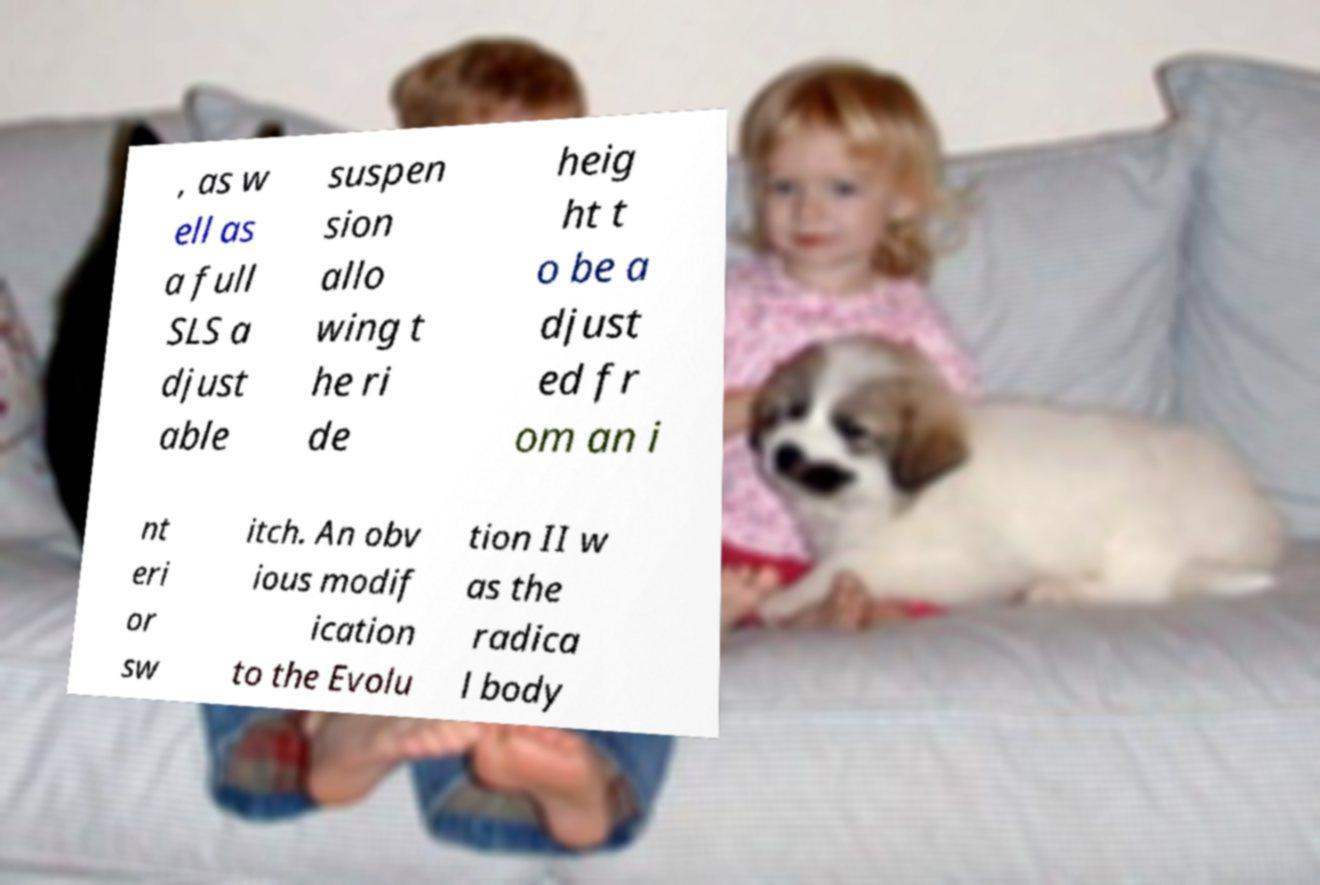Please read and relay the text visible in this image. What does it say? , as w ell as a full SLS a djust able suspen sion allo wing t he ri de heig ht t o be a djust ed fr om an i nt eri or sw itch. An obv ious modif ication to the Evolu tion II w as the radica l body 